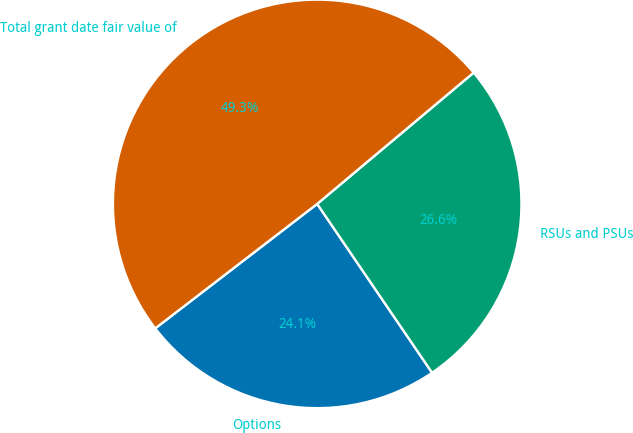<chart> <loc_0><loc_0><loc_500><loc_500><pie_chart><fcel>Options<fcel>RSUs and PSUs<fcel>Total grant date fair value of<nl><fcel>24.08%<fcel>26.6%<fcel>49.32%<nl></chart> 